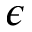<formula> <loc_0><loc_0><loc_500><loc_500>\epsilon</formula> 